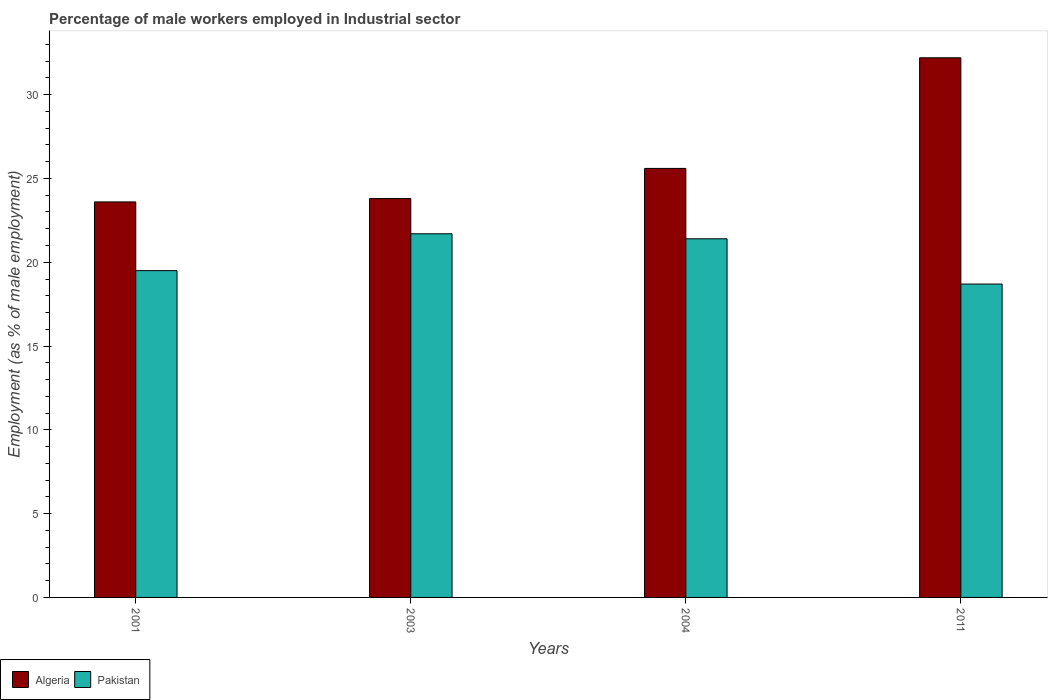How many bars are there on the 2nd tick from the right?
Make the answer very short. 2. What is the percentage of male workers employed in Industrial sector in Pakistan in 2011?
Your response must be concise. 18.7. Across all years, what is the maximum percentage of male workers employed in Industrial sector in Algeria?
Provide a short and direct response. 32.2. Across all years, what is the minimum percentage of male workers employed in Industrial sector in Pakistan?
Your response must be concise. 18.7. In which year was the percentage of male workers employed in Industrial sector in Algeria maximum?
Give a very brief answer. 2011. What is the total percentage of male workers employed in Industrial sector in Algeria in the graph?
Offer a terse response. 105.2. What is the difference between the percentage of male workers employed in Industrial sector in Pakistan in 2001 and that in 2003?
Give a very brief answer. -2.2. What is the difference between the percentage of male workers employed in Industrial sector in Pakistan in 2011 and the percentage of male workers employed in Industrial sector in Algeria in 2003?
Ensure brevity in your answer.  -5.1. What is the average percentage of male workers employed in Industrial sector in Algeria per year?
Your response must be concise. 26.3. In the year 2001, what is the difference between the percentage of male workers employed in Industrial sector in Pakistan and percentage of male workers employed in Industrial sector in Algeria?
Offer a terse response. -4.1. What is the ratio of the percentage of male workers employed in Industrial sector in Pakistan in 2003 to that in 2011?
Your answer should be very brief. 1.16. What is the difference between the highest and the second highest percentage of male workers employed in Industrial sector in Algeria?
Make the answer very short. 6.6. What is the difference between the highest and the lowest percentage of male workers employed in Industrial sector in Algeria?
Your answer should be very brief. 8.6. What does the 2nd bar from the left in 2004 represents?
Offer a very short reply. Pakistan. How many years are there in the graph?
Offer a terse response. 4. What is the difference between two consecutive major ticks on the Y-axis?
Give a very brief answer. 5. Does the graph contain grids?
Offer a terse response. No. Where does the legend appear in the graph?
Provide a succinct answer. Bottom left. How many legend labels are there?
Provide a succinct answer. 2. How are the legend labels stacked?
Provide a succinct answer. Horizontal. What is the title of the graph?
Keep it short and to the point. Percentage of male workers employed in Industrial sector. Does "High income" appear as one of the legend labels in the graph?
Give a very brief answer. No. What is the label or title of the X-axis?
Offer a very short reply. Years. What is the label or title of the Y-axis?
Keep it short and to the point. Employment (as % of male employment). What is the Employment (as % of male employment) of Algeria in 2001?
Your answer should be compact. 23.6. What is the Employment (as % of male employment) of Pakistan in 2001?
Give a very brief answer. 19.5. What is the Employment (as % of male employment) in Algeria in 2003?
Provide a succinct answer. 23.8. What is the Employment (as % of male employment) in Pakistan in 2003?
Make the answer very short. 21.7. What is the Employment (as % of male employment) of Algeria in 2004?
Offer a terse response. 25.6. What is the Employment (as % of male employment) in Pakistan in 2004?
Offer a terse response. 21.4. What is the Employment (as % of male employment) in Algeria in 2011?
Keep it short and to the point. 32.2. What is the Employment (as % of male employment) in Pakistan in 2011?
Ensure brevity in your answer.  18.7. Across all years, what is the maximum Employment (as % of male employment) of Algeria?
Make the answer very short. 32.2. Across all years, what is the maximum Employment (as % of male employment) in Pakistan?
Provide a short and direct response. 21.7. Across all years, what is the minimum Employment (as % of male employment) of Algeria?
Provide a succinct answer. 23.6. Across all years, what is the minimum Employment (as % of male employment) of Pakistan?
Your answer should be compact. 18.7. What is the total Employment (as % of male employment) of Algeria in the graph?
Ensure brevity in your answer.  105.2. What is the total Employment (as % of male employment) of Pakistan in the graph?
Provide a succinct answer. 81.3. What is the difference between the Employment (as % of male employment) in Algeria in 2001 and that in 2003?
Ensure brevity in your answer.  -0.2. What is the difference between the Employment (as % of male employment) of Pakistan in 2001 and that in 2004?
Offer a very short reply. -1.9. What is the difference between the Employment (as % of male employment) of Algeria in 2001 and that in 2011?
Keep it short and to the point. -8.6. What is the difference between the Employment (as % of male employment) in Pakistan in 2001 and that in 2011?
Offer a terse response. 0.8. What is the difference between the Employment (as % of male employment) of Algeria in 2003 and that in 2004?
Offer a terse response. -1.8. What is the difference between the Employment (as % of male employment) in Algeria in 2004 and that in 2011?
Provide a succinct answer. -6.6. What is the difference between the Employment (as % of male employment) in Algeria in 2001 and the Employment (as % of male employment) in Pakistan in 2004?
Provide a short and direct response. 2.2. What is the difference between the Employment (as % of male employment) in Algeria in 2001 and the Employment (as % of male employment) in Pakistan in 2011?
Offer a terse response. 4.9. What is the difference between the Employment (as % of male employment) in Algeria in 2003 and the Employment (as % of male employment) in Pakistan in 2004?
Offer a terse response. 2.4. What is the difference between the Employment (as % of male employment) in Algeria in 2004 and the Employment (as % of male employment) in Pakistan in 2011?
Keep it short and to the point. 6.9. What is the average Employment (as % of male employment) in Algeria per year?
Offer a terse response. 26.3. What is the average Employment (as % of male employment) in Pakistan per year?
Your answer should be very brief. 20.32. In the year 2011, what is the difference between the Employment (as % of male employment) in Algeria and Employment (as % of male employment) in Pakistan?
Your answer should be very brief. 13.5. What is the ratio of the Employment (as % of male employment) in Algeria in 2001 to that in 2003?
Ensure brevity in your answer.  0.99. What is the ratio of the Employment (as % of male employment) in Pakistan in 2001 to that in 2003?
Provide a succinct answer. 0.9. What is the ratio of the Employment (as % of male employment) of Algeria in 2001 to that in 2004?
Keep it short and to the point. 0.92. What is the ratio of the Employment (as % of male employment) in Pakistan in 2001 to that in 2004?
Keep it short and to the point. 0.91. What is the ratio of the Employment (as % of male employment) of Algeria in 2001 to that in 2011?
Give a very brief answer. 0.73. What is the ratio of the Employment (as % of male employment) of Pakistan in 2001 to that in 2011?
Offer a terse response. 1.04. What is the ratio of the Employment (as % of male employment) of Algeria in 2003 to that in 2004?
Give a very brief answer. 0.93. What is the ratio of the Employment (as % of male employment) of Algeria in 2003 to that in 2011?
Your answer should be compact. 0.74. What is the ratio of the Employment (as % of male employment) in Pakistan in 2003 to that in 2011?
Provide a succinct answer. 1.16. What is the ratio of the Employment (as % of male employment) of Algeria in 2004 to that in 2011?
Offer a terse response. 0.8. What is the ratio of the Employment (as % of male employment) of Pakistan in 2004 to that in 2011?
Make the answer very short. 1.14. What is the difference between the highest and the second highest Employment (as % of male employment) in Algeria?
Make the answer very short. 6.6. 